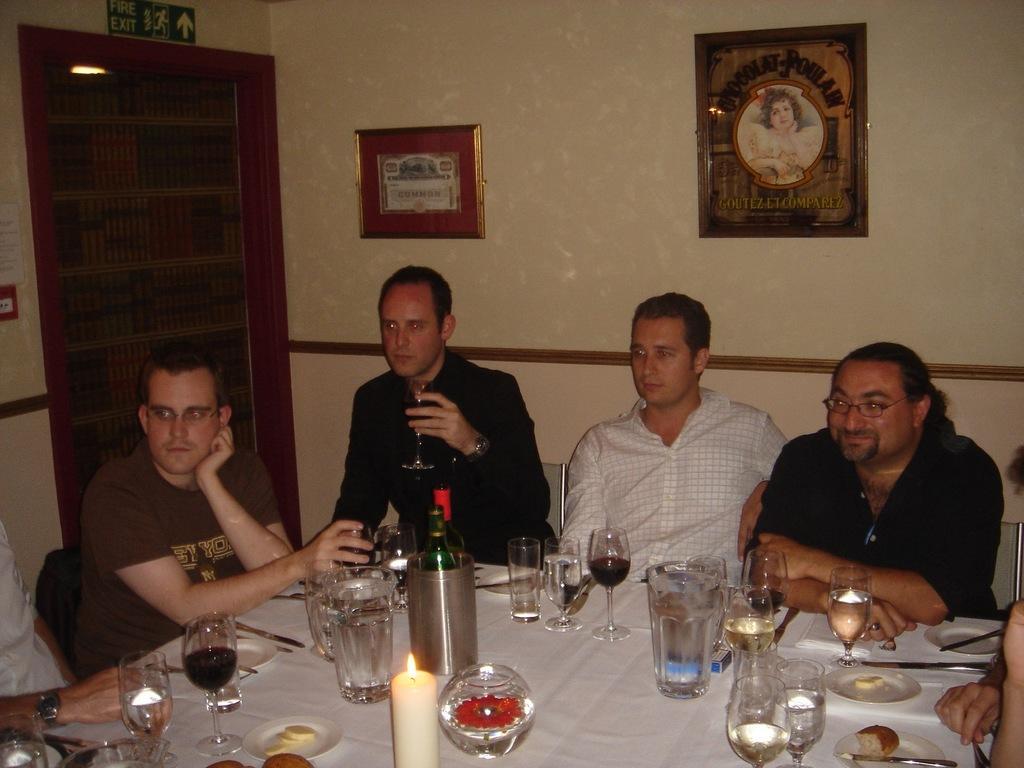In one or two sentences, can you explain what this image depicts? In this picture we can see some persons are sitting on the chairs. This is table. On the table there are glasses, bottle, and a candle. On the background there is a wall and these are the frames. And this is door. 